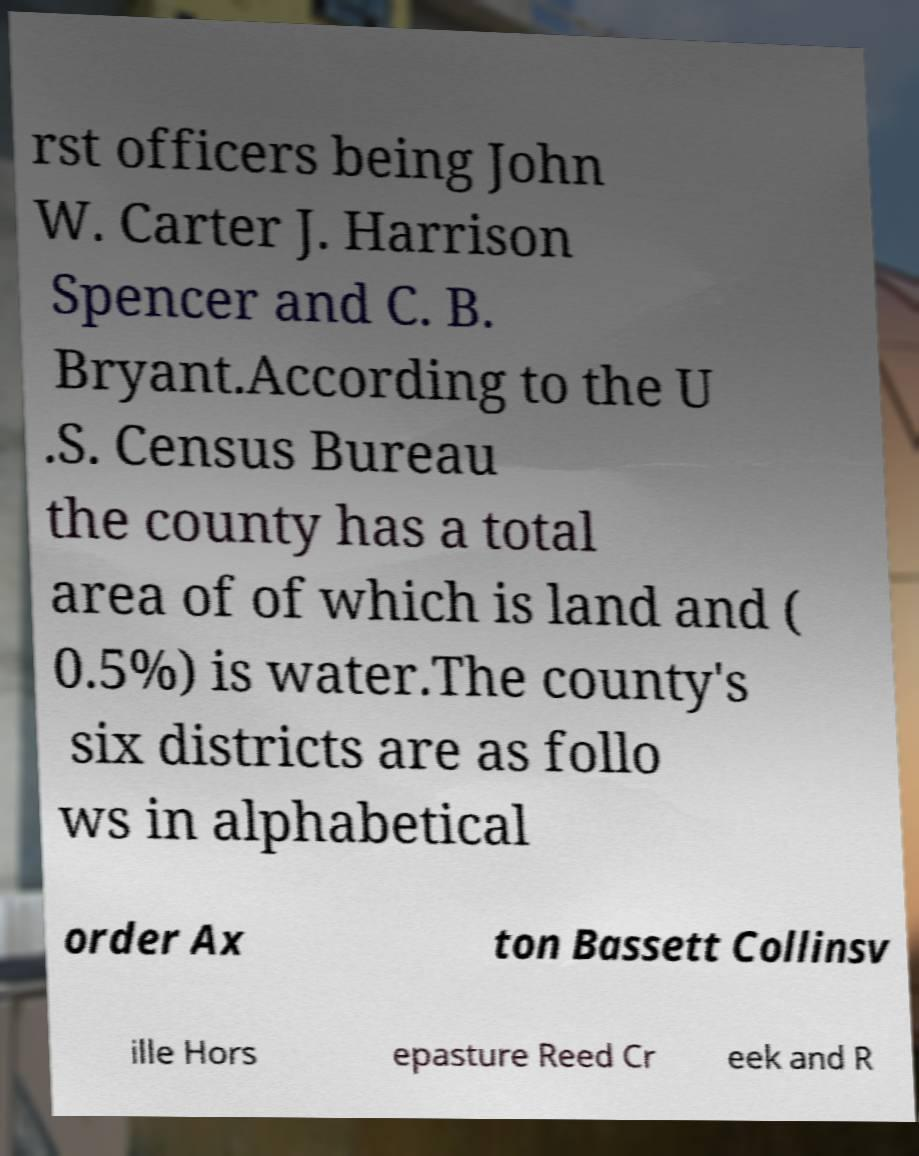Please identify and transcribe the text found in this image. rst officers being John W. Carter J. Harrison Spencer and C. B. Bryant.According to the U .S. Census Bureau the county has a total area of of which is land and ( 0.5%) is water.The county's six districts are as follo ws in alphabetical order Ax ton Bassett Collinsv ille Hors epasture Reed Cr eek and R 